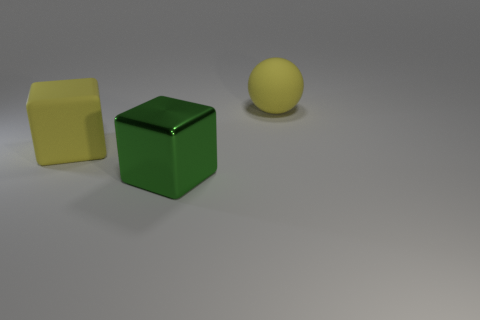How do the textures of the objects in the image compare? The objects in the image have distinct textures. The yellow sphere has a smooth, matte surface, suggestive of a rubber texture. The green cube displays reflections that suggest a harder, possibly plastic or painted surface, whereas the yellow cube seems to have a slightly softer sheen, which could imply a textured paint or different type of plastic with a satin finish. 